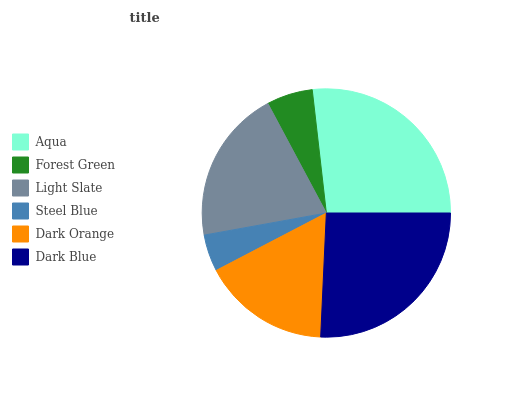Is Steel Blue the minimum?
Answer yes or no. Yes. Is Aqua the maximum?
Answer yes or no. Yes. Is Forest Green the minimum?
Answer yes or no. No. Is Forest Green the maximum?
Answer yes or no. No. Is Aqua greater than Forest Green?
Answer yes or no. Yes. Is Forest Green less than Aqua?
Answer yes or no. Yes. Is Forest Green greater than Aqua?
Answer yes or no. No. Is Aqua less than Forest Green?
Answer yes or no. No. Is Light Slate the high median?
Answer yes or no. Yes. Is Dark Orange the low median?
Answer yes or no. Yes. Is Forest Green the high median?
Answer yes or no. No. Is Aqua the low median?
Answer yes or no. No. 